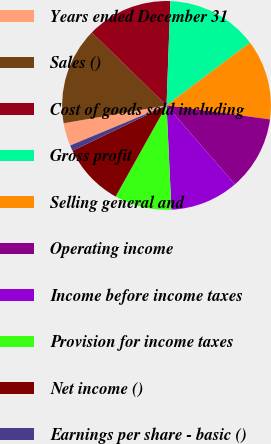Convert chart to OTSL. <chart><loc_0><loc_0><loc_500><loc_500><pie_chart><fcel>Years ended December 31<fcel>Sales ()<fcel>Cost of goods sold including<fcel>Gross profit<fcel>Selling general and<fcel>Operating income<fcel>Income before income taxes<fcel>Provision for income taxes<fcel>Net income ()<fcel>Earnings per share - basic ()<nl><fcel>3.54%<fcel>15.04%<fcel>13.27%<fcel>14.16%<fcel>12.39%<fcel>11.5%<fcel>10.62%<fcel>8.85%<fcel>9.73%<fcel>0.88%<nl></chart> 